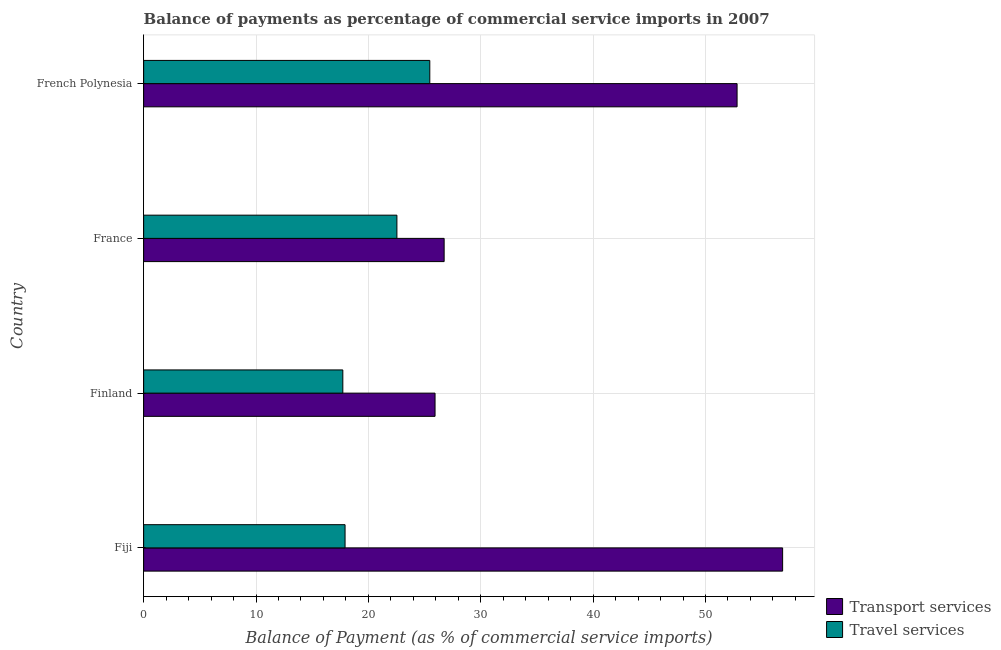Are the number of bars on each tick of the Y-axis equal?
Your answer should be very brief. Yes. How many bars are there on the 4th tick from the top?
Make the answer very short. 2. How many bars are there on the 2nd tick from the bottom?
Your answer should be compact. 2. What is the label of the 1st group of bars from the top?
Provide a short and direct response. French Polynesia. What is the balance of payments of transport services in French Polynesia?
Your answer should be compact. 52.81. Across all countries, what is the maximum balance of payments of travel services?
Provide a succinct answer. 25.46. Across all countries, what is the minimum balance of payments of travel services?
Keep it short and to the point. 17.73. In which country was the balance of payments of transport services maximum?
Your answer should be very brief. Fiji. What is the total balance of payments of travel services in the graph?
Keep it short and to the point. 83.65. What is the difference between the balance of payments of transport services in Fiji and that in France?
Your answer should be compact. 30.12. What is the difference between the balance of payments of transport services in Finland and the balance of payments of travel services in France?
Your answer should be compact. 3.39. What is the average balance of payments of transport services per country?
Your answer should be very brief. 40.59. What is the difference between the balance of payments of travel services and balance of payments of transport services in French Polynesia?
Give a very brief answer. -27.35. In how many countries, is the balance of payments of transport services greater than 6 %?
Offer a very short reply. 4. What is the ratio of the balance of payments of transport services in Fiji to that in French Polynesia?
Ensure brevity in your answer.  1.08. Is the balance of payments of transport services in France less than that in French Polynesia?
Provide a succinct answer. Yes. What is the difference between the highest and the second highest balance of payments of travel services?
Give a very brief answer. 2.93. What is the difference between the highest and the lowest balance of payments of travel services?
Provide a succinct answer. 7.74. In how many countries, is the balance of payments of transport services greater than the average balance of payments of transport services taken over all countries?
Your answer should be very brief. 2. What does the 1st bar from the top in France represents?
Your response must be concise. Travel services. What does the 1st bar from the bottom in France represents?
Offer a very short reply. Transport services. How many bars are there?
Ensure brevity in your answer.  8. How many countries are there in the graph?
Ensure brevity in your answer.  4. What is the difference between two consecutive major ticks on the X-axis?
Your answer should be very brief. 10. Does the graph contain grids?
Keep it short and to the point. Yes. Where does the legend appear in the graph?
Offer a very short reply. Bottom right. What is the title of the graph?
Provide a succinct answer. Balance of payments as percentage of commercial service imports in 2007. Does "Investment in Transport" appear as one of the legend labels in the graph?
Your answer should be very brief. No. What is the label or title of the X-axis?
Ensure brevity in your answer.  Balance of Payment (as % of commercial service imports). What is the Balance of Payment (as % of commercial service imports) in Transport services in Fiji?
Provide a succinct answer. 56.86. What is the Balance of Payment (as % of commercial service imports) in Travel services in Fiji?
Offer a very short reply. 17.92. What is the Balance of Payment (as % of commercial service imports) of Transport services in Finland?
Your answer should be compact. 25.93. What is the Balance of Payment (as % of commercial service imports) of Travel services in Finland?
Provide a succinct answer. 17.73. What is the Balance of Payment (as % of commercial service imports) of Transport services in France?
Provide a succinct answer. 26.74. What is the Balance of Payment (as % of commercial service imports) in Travel services in France?
Offer a terse response. 22.54. What is the Balance of Payment (as % of commercial service imports) in Transport services in French Polynesia?
Your answer should be very brief. 52.81. What is the Balance of Payment (as % of commercial service imports) in Travel services in French Polynesia?
Your answer should be compact. 25.46. Across all countries, what is the maximum Balance of Payment (as % of commercial service imports) in Transport services?
Make the answer very short. 56.86. Across all countries, what is the maximum Balance of Payment (as % of commercial service imports) in Travel services?
Keep it short and to the point. 25.46. Across all countries, what is the minimum Balance of Payment (as % of commercial service imports) in Transport services?
Your response must be concise. 25.93. Across all countries, what is the minimum Balance of Payment (as % of commercial service imports) in Travel services?
Your answer should be very brief. 17.73. What is the total Balance of Payment (as % of commercial service imports) in Transport services in the graph?
Your response must be concise. 162.35. What is the total Balance of Payment (as % of commercial service imports) in Travel services in the graph?
Your answer should be very brief. 83.65. What is the difference between the Balance of Payment (as % of commercial service imports) of Transport services in Fiji and that in Finland?
Your response must be concise. 30.93. What is the difference between the Balance of Payment (as % of commercial service imports) in Travel services in Fiji and that in Finland?
Your response must be concise. 0.2. What is the difference between the Balance of Payment (as % of commercial service imports) of Transport services in Fiji and that in France?
Give a very brief answer. 30.12. What is the difference between the Balance of Payment (as % of commercial service imports) in Travel services in Fiji and that in France?
Offer a terse response. -4.61. What is the difference between the Balance of Payment (as % of commercial service imports) of Transport services in Fiji and that in French Polynesia?
Ensure brevity in your answer.  4.05. What is the difference between the Balance of Payment (as % of commercial service imports) of Travel services in Fiji and that in French Polynesia?
Make the answer very short. -7.54. What is the difference between the Balance of Payment (as % of commercial service imports) in Transport services in Finland and that in France?
Offer a very short reply. -0.81. What is the difference between the Balance of Payment (as % of commercial service imports) of Travel services in Finland and that in France?
Make the answer very short. -4.81. What is the difference between the Balance of Payment (as % of commercial service imports) in Transport services in Finland and that in French Polynesia?
Provide a short and direct response. -26.88. What is the difference between the Balance of Payment (as % of commercial service imports) of Travel services in Finland and that in French Polynesia?
Ensure brevity in your answer.  -7.74. What is the difference between the Balance of Payment (as % of commercial service imports) of Transport services in France and that in French Polynesia?
Keep it short and to the point. -26.07. What is the difference between the Balance of Payment (as % of commercial service imports) of Travel services in France and that in French Polynesia?
Offer a very short reply. -2.93. What is the difference between the Balance of Payment (as % of commercial service imports) of Transport services in Fiji and the Balance of Payment (as % of commercial service imports) of Travel services in Finland?
Offer a very short reply. 39.14. What is the difference between the Balance of Payment (as % of commercial service imports) of Transport services in Fiji and the Balance of Payment (as % of commercial service imports) of Travel services in France?
Your answer should be compact. 34.33. What is the difference between the Balance of Payment (as % of commercial service imports) in Transport services in Fiji and the Balance of Payment (as % of commercial service imports) in Travel services in French Polynesia?
Your answer should be compact. 31.4. What is the difference between the Balance of Payment (as % of commercial service imports) of Transport services in Finland and the Balance of Payment (as % of commercial service imports) of Travel services in France?
Your response must be concise. 3.4. What is the difference between the Balance of Payment (as % of commercial service imports) of Transport services in Finland and the Balance of Payment (as % of commercial service imports) of Travel services in French Polynesia?
Your answer should be compact. 0.47. What is the difference between the Balance of Payment (as % of commercial service imports) of Transport services in France and the Balance of Payment (as % of commercial service imports) of Travel services in French Polynesia?
Your response must be concise. 1.28. What is the average Balance of Payment (as % of commercial service imports) of Transport services per country?
Provide a succinct answer. 40.59. What is the average Balance of Payment (as % of commercial service imports) of Travel services per country?
Your answer should be compact. 20.91. What is the difference between the Balance of Payment (as % of commercial service imports) in Transport services and Balance of Payment (as % of commercial service imports) in Travel services in Fiji?
Your answer should be very brief. 38.94. What is the difference between the Balance of Payment (as % of commercial service imports) in Transport services and Balance of Payment (as % of commercial service imports) in Travel services in Finland?
Keep it short and to the point. 8.21. What is the difference between the Balance of Payment (as % of commercial service imports) in Transport services and Balance of Payment (as % of commercial service imports) in Travel services in France?
Ensure brevity in your answer.  4.2. What is the difference between the Balance of Payment (as % of commercial service imports) of Transport services and Balance of Payment (as % of commercial service imports) of Travel services in French Polynesia?
Ensure brevity in your answer.  27.35. What is the ratio of the Balance of Payment (as % of commercial service imports) of Transport services in Fiji to that in Finland?
Make the answer very short. 2.19. What is the ratio of the Balance of Payment (as % of commercial service imports) in Travel services in Fiji to that in Finland?
Ensure brevity in your answer.  1.01. What is the ratio of the Balance of Payment (as % of commercial service imports) of Transport services in Fiji to that in France?
Provide a short and direct response. 2.13. What is the ratio of the Balance of Payment (as % of commercial service imports) of Travel services in Fiji to that in France?
Give a very brief answer. 0.8. What is the ratio of the Balance of Payment (as % of commercial service imports) of Transport services in Fiji to that in French Polynesia?
Provide a succinct answer. 1.08. What is the ratio of the Balance of Payment (as % of commercial service imports) of Travel services in Fiji to that in French Polynesia?
Provide a succinct answer. 0.7. What is the ratio of the Balance of Payment (as % of commercial service imports) in Transport services in Finland to that in France?
Make the answer very short. 0.97. What is the ratio of the Balance of Payment (as % of commercial service imports) in Travel services in Finland to that in France?
Give a very brief answer. 0.79. What is the ratio of the Balance of Payment (as % of commercial service imports) of Transport services in Finland to that in French Polynesia?
Ensure brevity in your answer.  0.49. What is the ratio of the Balance of Payment (as % of commercial service imports) of Travel services in Finland to that in French Polynesia?
Offer a terse response. 0.7. What is the ratio of the Balance of Payment (as % of commercial service imports) in Transport services in France to that in French Polynesia?
Ensure brevity in your answer.  0.51. What is the ratio of the Balance of Payment (as % of commercial service imports) of Travel services in France to that in French Polynesia?
Give a very brief answer. 0.89. What is the difference between the highest and the second highest Balance of Payment (as % of commercial service imports) of Transport services?
Keep it short and to the point. 4.05. What is the difference between the highest and the second highest Balance of Payment (as % of commercial service imports) in Travel services?
Provide a short and direct response. 2.93. What is the difference between the highest and the lowest Balance of Payment (as % of commercial service imports) of Transport services?
Your answer should be compact. 30.93. What is the difference between the highest and the lowest Balance of Payment (as % of commercial service imports) of Travel services?
Your answer should be compact. 7.74. 